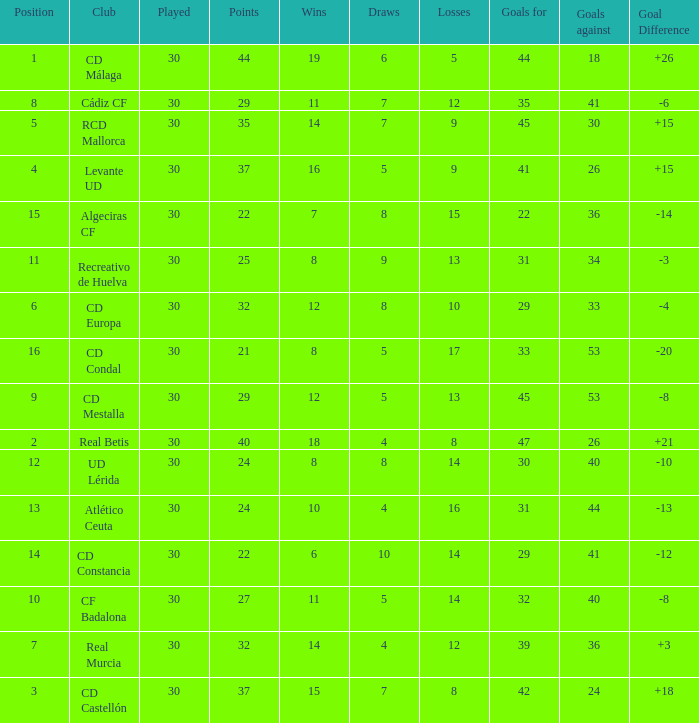What is the wins number when the points were smaller than 27, and goals against was 41? 6.0. 